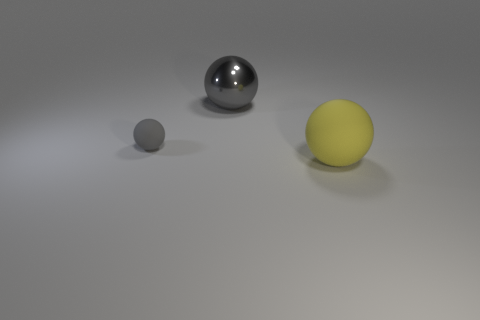There is a matte object that is the same color as the metallic sphere; what is its size?
Keep it short and to the point. Small. Is there any other thing that is the same size as the gray metallic sphere?
Your answer should be compact. Yes. What color is the ball that is both on the right side of the gray matte object and left of the big yellow ball?
Provide a short and direct response. Gray. Do the gray thing left of the shiny thing and the big yellow thing have the same material?
Provide a short and direct response. Yes. Does the small thing have the same color as the rubber sphere that is in front of the tiny gray matte ball?
Make the answer very short. No. There is a yellow sphere; are there any metal balls on the right side of it?
Your response must be concise. No. Does the gray sphere in front of the large gray metallic ball have the same size as the sphere that is to the right of the large gray object?
Ensure brevity in your answer.  No. Is there a red matte object of the same size as the yellow rubber object?
Ensure brevity in your answer.  No. There is a big object in front of the large gray thing; is it the same shape as the tiny gray thing?
Provide a short and direct response. Yes. There is a ball in front of the tiny gray matte thing; what is it made of?
Give a very brief answer. Rubber. 